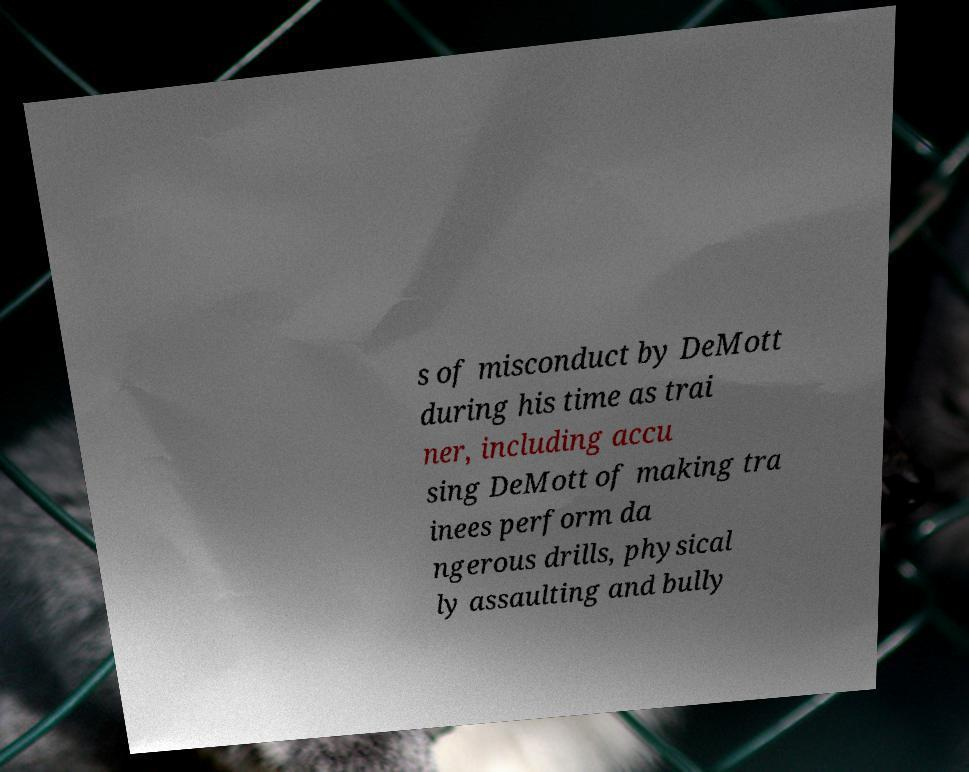Can you read and provide the text displayed in the image?This photo seems to have some interesting text. Can you extract and type it out for me? s of misconduct by DeMott during his time as trai ner, including accu sing DeMott of making tra inees perform da ngerous drills, physical ly assaulting and bully 